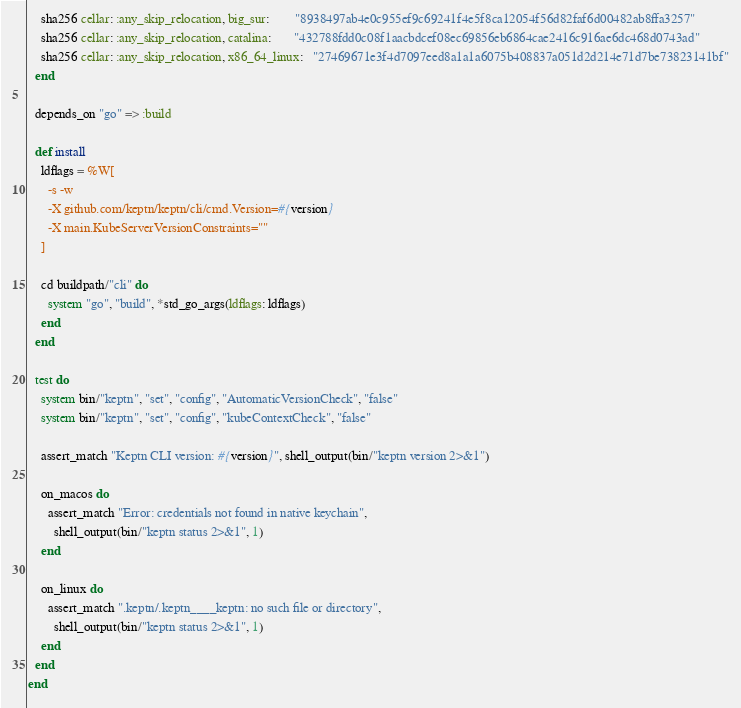<code> <loc_0><loc_0><loc_500><loc_500><_Ruby_>    sha256 cellar: :any_skip_relocation, big_sur:        "8938497ab4e0c955ef9c69241f4e5f8ca12054f56d82faf6d00482ab8ffa3257"
    sha256 cellar: :any_skip_relocation, catalina:       "432788fdd0c08f1aacbdcef08ec69856eb6864cae2416c916ae6dc468d0743ad"
    sha256 cellar: :any_skip_relocation, x86_64_linux:   "27469671e3f4d7097eed8a1a1a6075b408837a051d2d214e71d7be73823141bf"
  end

  depends_on "go" => :build

  def install
    ldflags = %W[
      -s -w
      -X github.com/keptn/keptn/cli/cmd.Version=#{version}
      -X main.KubeServerVersionConstraints=""
    ]

    cd buildpath/"cli" do
      system "go", "build", *std_go_args(ldflags: ldflags)
    end
  end

  test do
    system bin/"keptn", "set", "config", "AutomaticVersionCheck", "false"
    system bin/"keptn", "set", "config", "kubeContextCheck", "false"

    assert_match "Keptn CLI version: #{version}", shell_output(bin/"keptn version 2>&1")

    on_macos do
      assert_match "Error: credentials not found in native keychain",
        shell_output(bin/"keptn status 2>&1", 1)
    end

    on_linux do
      assert_match ".keptn/.keptn____keptn: no such file or directory",
        shell_output(bin/"keptn status 2>&1", 1)
    end
  end
end
</code> 